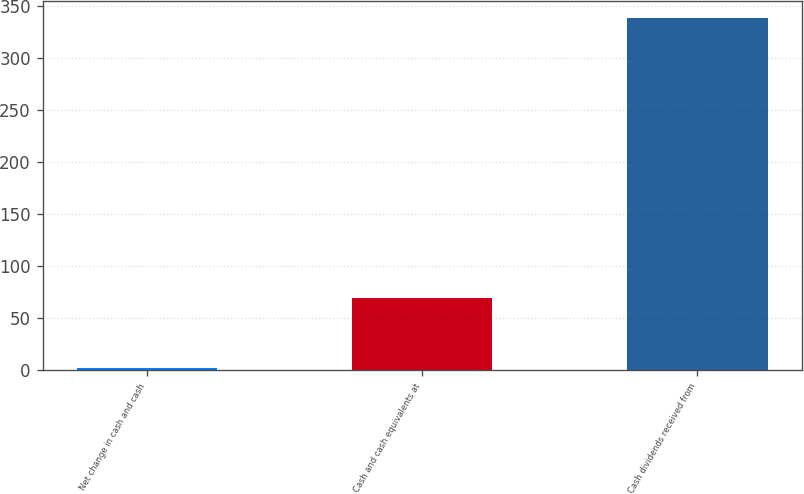Convert chart to OTSL. <chart><loc_0><loc_0><loc_500><loc_500><bar_chart><fcel>Net change in cash and cash<fcel>Cash and cash equivalents at<fcel>Cash dividends received from<nl><fcel>2<fcel>69.2<fcel>338<nl></chart> 